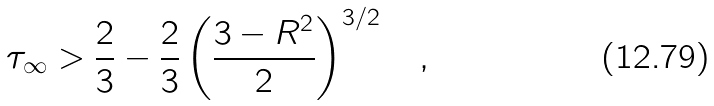Convert formula to latex. <formula><loc_0><loc_0><loc_500><loc_500>\tau _ { \infty } > \frac { 2 } { 3 } - \frac { 2 } { 3 } \left ( \frac { 3 - R ^ { 2 } } { 2 } \right ) ^ { 3 / 2 } \quad ,</formula> 